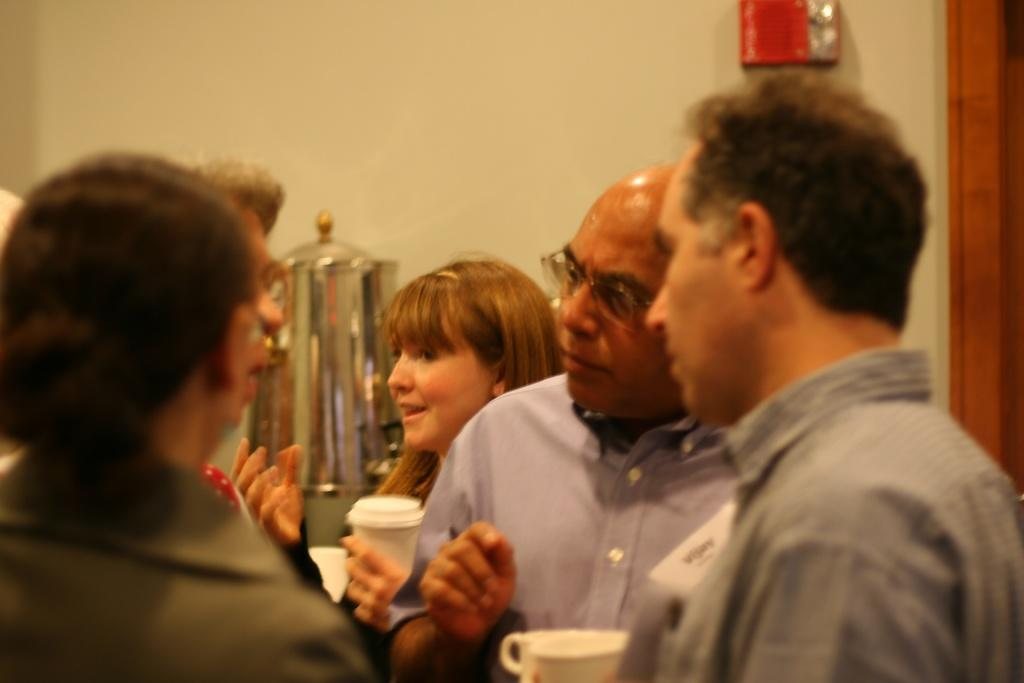How many people are in the image? There is a group of people in the image. What are two of the people holding in their hands? Two persons are holding cups in their hands. What can be seen in the background of the image? There is a container and a box on the wall in the background of the image. How many babies are crawling on the floor in the image? There are no babies present in the image. What direction is the way leading to in the image? There is no way or path visible in the image. 